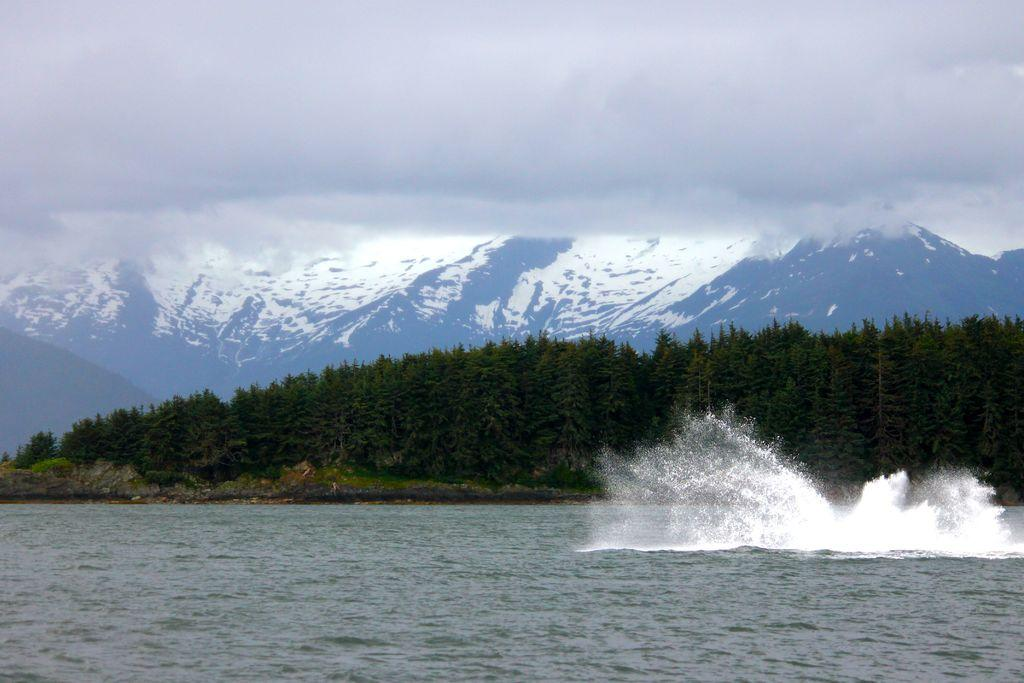What type of natural environment is depicted in the image? The image features many trees, mountains in the background, and the sea visible at the bottom. What is the condition of the sky in the image? The sky is cloudy at the top of the image. Where is the market located in the image? There is no market present in the image; it features a natural landscape with trees, mountains, the sea, and a cloudy sky. Can you see any cobwebs in the image? There are no cobwebs present in the image, as it depicts a natural landscape without any man-made structures or objects. 